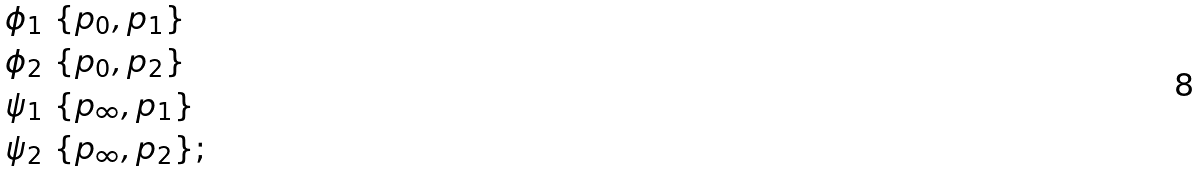Convert formula to latex. <formula><loc_0><loc_0><loc_500><loc_500>\phi _ { 1 } & \ \{ p _ { 0 } , p _ { 1 } \} \\ \phi _ { 2 } & \ \{ p _ { 0 } , p _ { 2 } \} \\ \psi _ { 1 } & \ \{ p _ { \infty } , p _ { 1 } \} \\ \psi _ { 2 } & \ \{ p _ { \infty } , p _ { 2 } \} ;</formula> 